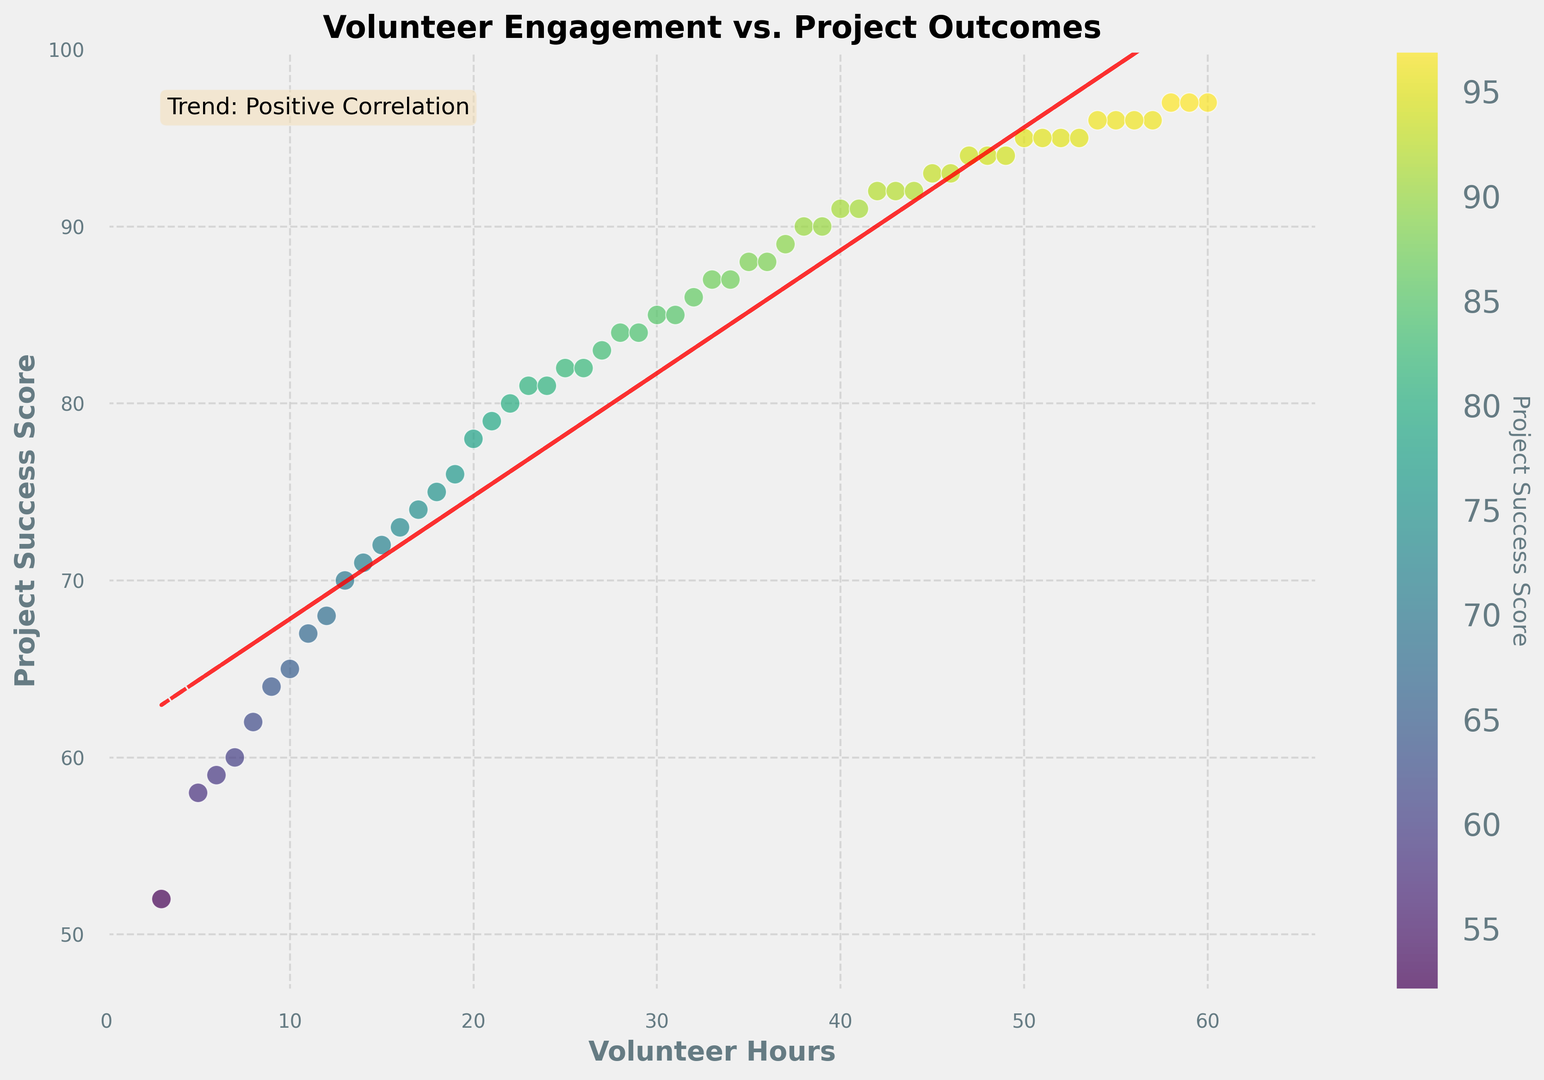What is the range of volunteer hours observed in the plot? The range is the difference between the maximum and minimum values. The minimum value is 3 hours and the maximum value is 60 hours, so the range is 60 - 3.
Answer: 57 hours What is the general trend observed between volunteer hours and project success scores? The scatter plot shows a positive trend line, indicating that project success scores increase as volunteer hours increase.
Answer: Positive correlation Which data point has the highest project success score and what are its volunteer hours? The scatter plot's topmost data point represents the highest project success score. This score is 97, and the corresponding volunteer hours are 60.
Answer: 60 hours How does the project success score change when volunteer hours increase from 10 to 20? The project success score increases from 65 to 78 when volunteer hours increase from 10 to 20.
Answer: Increases from 65 to 78 What is the approximate equation of the trend line shown in the plot? The trend line is represented by the equation of the line fitted to the data. In this plot, this equation is a linear regression fit. The coefficients are visually indicated near the trend line, approximately y = 0.8x + 55.
Answer: y = 0.8x + 55 Compare the project success scores for volunteer hours of 18 and 28. Which one is higher and by how much? For 18 volunteer hours, the score is 75, and for 28 volunteer hours, the score is 84. The difference is 84 - 75.
Answer: 28 hours by 9 points What does the color gradient in the scatter plot represent? The color gradient from shades of blue to green to yellow indicates the project success score, with darker colors representing lower scores and lighter colors representing higher scores.
Answer: Project success score Is there any visible outlier in the plot based on the volunteer hours vs. project success score? Outliers are data points that do not fit the general trend. All data points appear to follow the positive trend closely, so there are no visible outliers.
Answer: No visible outliers For two projects with 30 and 35 volunteer hours, what are their respective project success scores, and which one performed better? Projects with 30 and 35 volunteer hours have project success scores of 85 and 88, respectively. Since 88 is greater than 85, the project with 35 volunteer hours performed better.
Answer: 35 hours performed better What is the difference between the maximum and minimum project success scores observed in the plot? The minimum project success score is 52, and the maximum project success score is 97. The difference is 97 - 52.
Answer: 45 points 